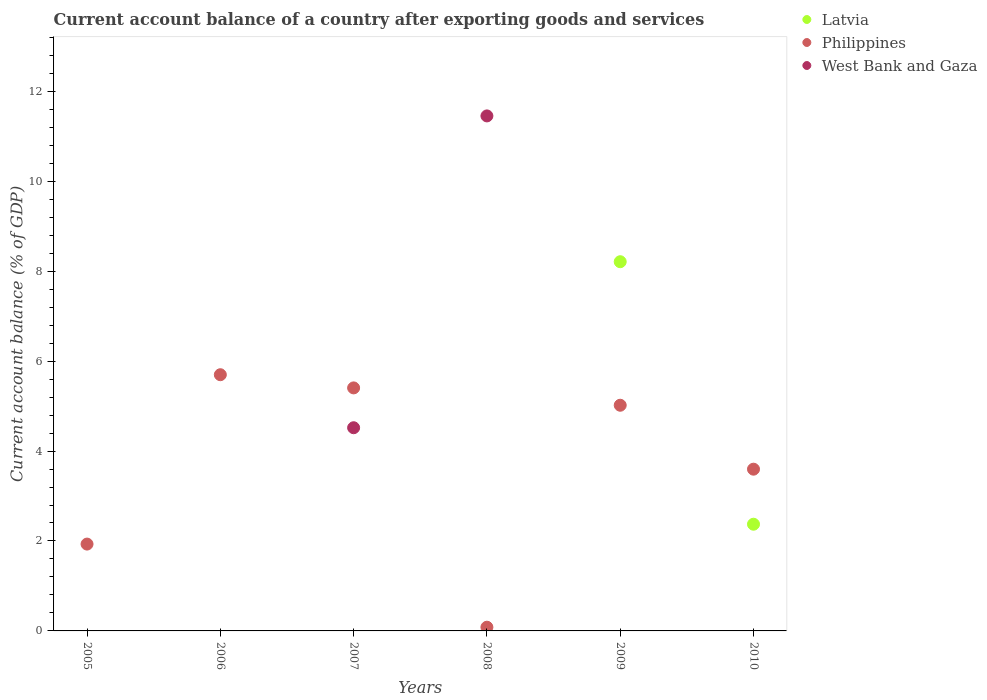What is the account balance in West Bank and Gaza in 2008?
Ensure brevity in your answer.  11.45. Across all years, what is the maximum account balance in Philippines?
Provide a succinct answer. 5.7. Across all years, what is the minimum account balance in Philippines?
Make the answer very short. 0.08. What is the total account balance in Latvia in the graph?
Keep it short and to the point. 10.58. What is the difference between the account balance in Philippines in 2005 and that in 2007?
Give a very brief answer. -3.47. What is the difference between the account balance in Latvia in 2009 and the account balance in West Bank and Gaza in 2008?
Provide a short and direct response. -3.24. What is the average account balance in West Bank and Gaza per year?
Make the answer very short. 2.66. In the year 2007, what is the difference between the account balance in Philippines and account balance in West Bank and Gaza?
Offer a very short reply. 0.89. In how many years, is the account balance in Latvia greater than 4.8 %?
Your answer should be very brief. 1. What is the ratio of the account balance in Philippines in 2005 to that in 2008?
Give a very brief answer. 23.36. What is the difference between the highest and the second highest account balance in Philippines?
Offer a very short reply. 0.29. What is the difference between the highest and the lowest account balance in West Bank and Gaza?
Offer a very short reply. 11.45. Is the sum of the account balance in Philippines in 2008 and 2009 greater than the maximum account balance in West Bank and Gaza across all years?
Provide a short and direct response. No. Does the account balance in West Bank and Gaza monotonically increase over the years?
Provide a short and direct response. No. Is the account balance in Philippines strictly greater than the account balance in Latvia over the years?
Give a very brief answer. No. Is the account balance in Philippines strictly less than the account balance in West Bank and Gaza over the years?
Your answer should be compact. No. How many dotlines are there?
Your response must be concise. 3. How many years are there in the graph?
Your answer should be very brief. 6. Are the values on the major ticks of Y-axis written in scientific E-notation?
Your answer should be very brief. No. What is the title of the graph?
Your answer should be compact. Current account balance of a country after exporting goods and services. What is the label or title of the X-axis?
Keep it short and to the point. Years. What is the label or title of the Y-axis?
Give a very brief answer. Current account balance (% of GDP). What is the Current account balance (% of GDP) of Latvia in 2005?
Your answer should be very brief. 0. What is the Current account balance (% of GDP) in Philippines in 2005?
Your response must be concise. 1.93. What is the Current account balance (% of GDP) of Latvia in 2006?
Keep it short and to the point. 0. What is the Current account balance (% of GDP) of Philippines in 2006?
Provide a short and direct response. 5.7. What is the Current account balance (% of GDP) in West Bank and Gaza in 2006?
Provide a short and direct response. 0. What is the Current account balance (% of GDP) in Latvia in 2007?
Your answer should be very brief. 0. What is the Current account balance (% of GDP) of Philippines in 2007?
Your response must be concise. 5.4. What is the Current account balance (% of GDP) in West Bank and Gaza in 2007?
Offer a very short reply. 4.52. What is the Current account balance (% of GDP) in Philippines in 2008?
Keep it short and to the point. 0.08. What is the Current account balance (% of GDP) in West Bank and Gaza in 2008?
Offer a terse response. 11.45. What is the Current account balance (% of GDP) in Latvia in 2009?
Give a very brief answer. 8.21. What is the Current account balance (% of GDP) in Philippines in 2009?
Provide a short and direct response. 5.02. What is the Current account balance (% of GDP) in West Bank and Gaza in 2009?
Your answer should be compact. 0. What is the Current account balance (% of GDP) of Latvia in 2010?
Your response must be concise. 2.37. What is the Current account balance (% of GDP) in Philippines in 2010?
Provide a short and direct response. 3.6. What is the Current account balance (% of GDP) in West Bank and Gaza in 2010?
Your answer should be compact. 0. Across all years, what is the maximum Current account balance (% of GDP) in Latvia?
Provide a succinct answer. 8.21. Across all years, what is the maximum Current account balance (% of GDP) in Philippines?
Your response must be concise. 5.7. Across all years, what is the maximum Current account balance (% of GDP) in West Bank and Gaza?
Make the answer very short. 11.45. Across all years, what is the minimum Current account balance (% of GDP) in Latvia?
Make the answer very short. 0. Across all years, what is the minimum Current account balance (% of GDP) in Philippines?
Your answer should be very brief. 0.08. Across all years, what is the minimum Current account balance (% of GDP) in West Bank and Gaza?
Offer a very short reply. 0. What is the total Current account balance (% of GDP) in Latvia in the graph?
Provide a succinct answer. 10.58. What is the total Current account balance (% of GDP) in Philippines in the graph?
Your answer should be very brief. 21.73. What is the total Current account balance (% of GDP) of West Bank and Gaza in the graph?
Your response must be concise. 15.97. What is the difference between the Current account balance (% of GDP) in Philippines in 2005 and that in 2006?
Your response must be concise. -3.77. What is the difference between the Current account balance (% of GDP) of Philippines in 2005 and that in 2007?
Make the answer very short. -3.47. What is the difference between the Current account balance (% of GDP) of Philippines in 2005 and that in 2008?
Your response must be concise. 1.85. What is the difference between the Current account balance (% of GDP) in Philippines in 2005 and that in 2009?
Your answer should be very brief. -3.09. What is the difference between the Current account balance (% of GDP) in Philippines in 2005 and that in 2010?
Offer a very short reply. -1.67. What is the difference between the Current account balance (% of GDP) in Philippines in 2006 and that in 2007?
Provide a short and direct response. 0.29. What is the difference between the Current account balance (% of GDP) in Philippines in 2006 and that in 2008?
Your answer should be compact. 5.61. What is the difference between the Current account balance (% of GDP) in Philippines in 2006 and that in 2009?
Provide a short and direct response. 0.68. What is the difference between the Current account balance (% of GDP) of Philippines in 2006 and that in 2010?
Your answer should be compact. 2.1. What is the difference between the Current account balance (% of GDP) in Philippines in 2007 and that in 2008?
Provide a short and direct response. 5.32. What is the difference between the Current account balance (% of GDP) in West Bank and Gaza in 2007 and that in 2008?
Your response must be concise. -6.93. What is the difference between the Current account balance (% of GDP) of Philippines in 2007 and that in 2009?
Keep it short and to the point. 0.39. What is the difference between the Current account balance (% of GDP) in Philippines in 2007 and that in 2010?
Provide a short and direct response. 1.81. What is the difference between the Current account balance (% of GDP) of Philippines in 2008 and that in 2009?
Give a very brief answer. -4.94. What is the difference between the Current account balance (% of GDP) in Philippines in 2008 and that in 2010?
Your response must be concise. -3.51. What is the difference between the Current account balance (% of GDP) in Latvia in 2009 and that in 2010?
Your answer should be compact. 5.84. What is the difference between the Current account balance (% of GDP) of Philippines in 2009 and that in 2010?
Provide a succinct answer. 1.42. What is the difference between the Current account balance (% of GDP) in Philippines in 2005 and the Current account balance (% of GDP) in West Bank and Gaza in 2007?
Your answer should be very brief. -2.59. What is the difference between the Current account balance (% of GDP) of Philippines in 2005 and the Current account balance (% of GDP) of West Bank and Gaza in 2008?
Ensure brevity in your answer.  -9.52. What is the difference between the Current account balance (% of GDP) in Philippines in 2006 and the Current account balance (% of GDP) in West Bank and Gaza in 2007?
Provide a succinct answer. 1.18. What is the difference between the Current account balance (% of GDP) of Philippines in 2006 and the Current account balance (% of GDP) of West Bank and Gaza in 2008?
Give a very brief answer. -5.76. What is the difference between the Current account balance (% of GDP) of Philippines in 2007 and the Current account balance (% of GDP) of West Bank and Gaza in 2008?
Offer a very short reply. -6.05. What is the difference between the Current account balance (% of GDP) of Latvia in 2009 and the Current account balance (% of GDP) of Philippines in 2010?
Offer a terse response. 4.61. What is the average Current account balance (% of GDP) in Latvia per year?
Give a very brief answer. 1.76. What is the average Current account balance (% of GDP) of Philippines per year?
Give a very brief answer. 3.62. What is the average Current account balance (% of GDP) in West Bank and Gaza per year?
Offer a terse response. 2.66. In the year 2007, what is the difference between the Current account balance (% of GDP) in Philippines and Current account balance (% of GDP) in West Bank and Gaza?
Offer a terse response. 0.89. In the year 2008, what is the difference between the Current account balance (% of GDP) of Philippines and Current account balance (% of GDP) of West Bank and Gaza?
Give a very brief answer. -11.37. In the year 2009, what is the difference between the Current account balance (% of GDP) in Latvia and Current account balance (% of GDP) in Philippines?
Give a very brief answer. 3.19. In the year 2010, what is the difference between the Current account balance (% of GDP) of Latvia and Current account balance (% of GDP) of Philippines?
Your answer should be compact. -1.22. What is the ratio of the Current account balance (% of GDP) in Philippines in 2005 to that in 2006?
Keep it short and to the point. 0.34. What is the ratio of the Current account balance (% of GDP) in Philippines in 2005 to that in 2007?
Provide a short and direct response. 0.36. What is the ratio of the Current account balance (% of GDP) in Philippines in 2005 to that in 2008?
Provide a short and direct response. 23.36. What is the ratio of the Current account balance (% of GDP) of Philippines in 2005 to that in 2009?
Ensure brevity in your answer.  0.38. What is the ratio of the Current account balance (% of GDP) in Philippines in 2005 to that in 2010?
Your answer should be very brief. 0.54. What is the ratio of the Current account balance (% of GDP) in Philippines in 2006 to that in 2007?
Make the answer very short. 1.05. What is the ratio of the Current account balance (% of GDP) in Philippines in 2006 to that in 2008?
Provide a succinct answer. 68.91. What is the ratio of the Current account balance (% of GDP) of Philippines in 2006 to that in 2009?
Provide a succinct answer. 1.14. What is the ratio of the Current account balance (% of GDP) in Philippines in 2006 to that in 2010?
Your response must be concise. 1.58. What is the ratio of the Current account balance (% of GDP) in Philippines in 2007 to that in 2008?
Make the answer very short. 65.37. What is the ratio of the Current account balance (% of GDP) in West Bank and Gaza in 2007 to that in 2008?
Make the answer very short. 0.39. What is the ratio of the Current account balance (% of GDP) of Philippines in 2007 to that in 2009?
Provide a short and direct response. 1.08. What is the ratio of the Current account balance (% of GDP) in Philippines in 2007 to that in 2010?
Offer a terse response. 1.5. What is the ratio of the Current account balance (% of GDP) of Philippines in 2008 to that in 2009?
Offer a very short reply. 0.02. What is the ratio of the Current account balance (% of GDP) in Philippines in 2008 to that in 2010?
Your answer should be compact. 0.02. What is the ratio of the Current account balance (% of GDP) in Latvia in 2009 to that in 2010?
Ensure brevity in your answer.  3.46. What is the ratio of the Current account balance (% of GDP) in Philippines in 2009 to that in 2010?
Provide a short and direct response. 1.4. What is the difference between the highest and the second highest Current account balance (% of GDP) in Philippines?
Offer a terse response. 0.29. What is the difference between the highest and the lowest Current account balance (% of GDP) of Latvia?
Make the answer very short. 8.21. What is the difference between the highest and the lowest Current account balance (% of GDP) in Philippines?
Make the answer very short. 5.61. What is the difference between the highest and the lowest Current account balance (% of GDP) in West Bank and Gaza?
Your response must be concise. 11.45. 